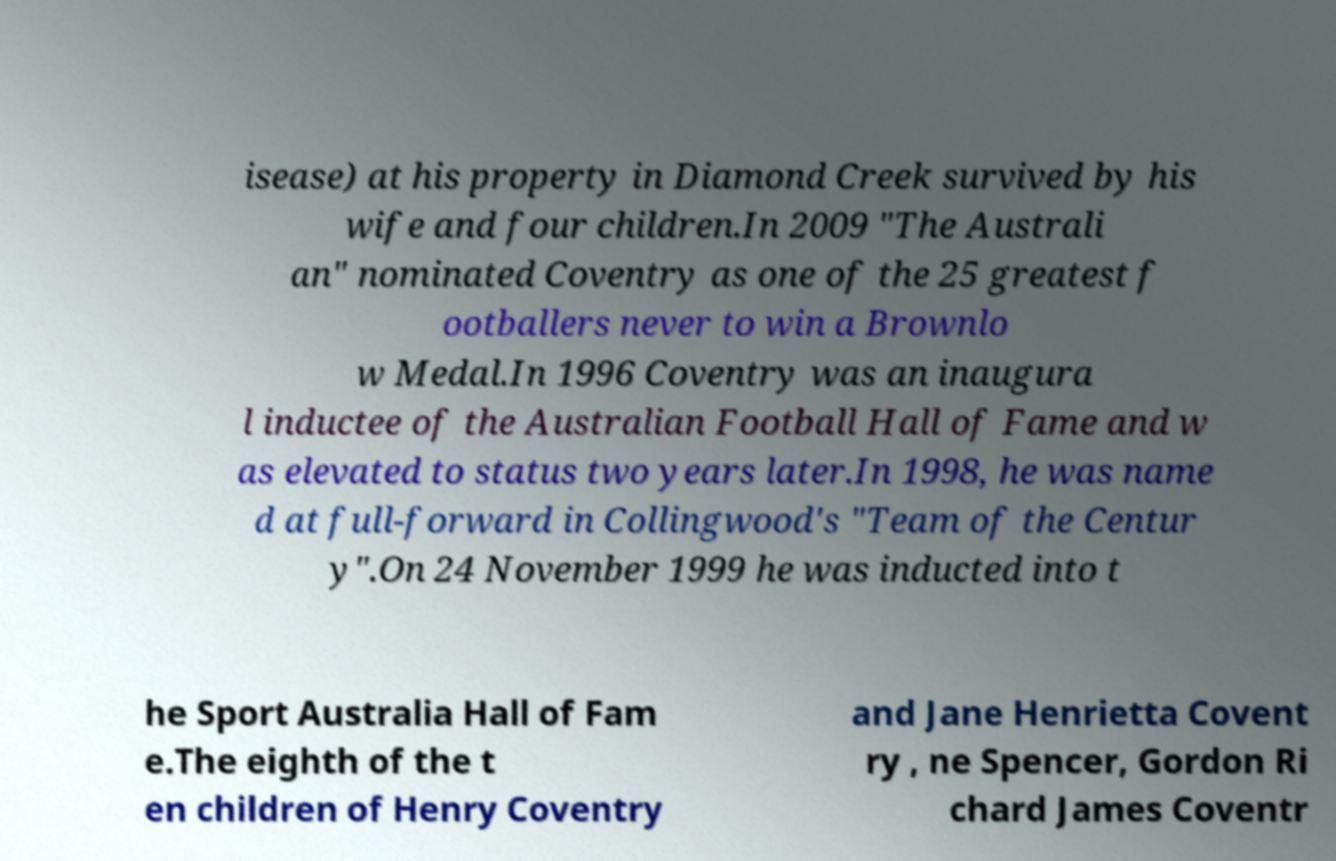What messages or text are displayed in this image? I need them in a readable, typed format. isease) at his property in Diamond Creek survived by his wife and four children.In 2009 "The Australi an" nominated Coventry as one of the 25 greatest f ootballers never to win a Brownlo w Medal.In 1996 Coventry was an inaugura l inductee of the Australian Football Hall of Fame and w as elevated to status two years later.In 1998, he was name d at full-forward in Collingwood's "Team of the Centur y".On 24 November 1999 he was inducted into t he Sport Australia Hall of Fam e.The eighth of the t en children of Henry Coventry and Jane Henrietta Covent ry , ne Spencer, Gordon Ri chard James Coventr 